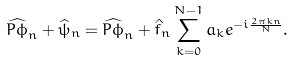<formula> <loc_0><loc_0><loc_500><loc_500>\widehat { P \phi } _ { n } + \widehat { \psi } _ { n } = \widehat { P \phi } _ { n } + \hat { f } _ { n } \sum _ { k = 0 } ^ { N - 1 } a _ { k } e ^ { - i \frac { 2 \pi k n } { N } } .</formula> 